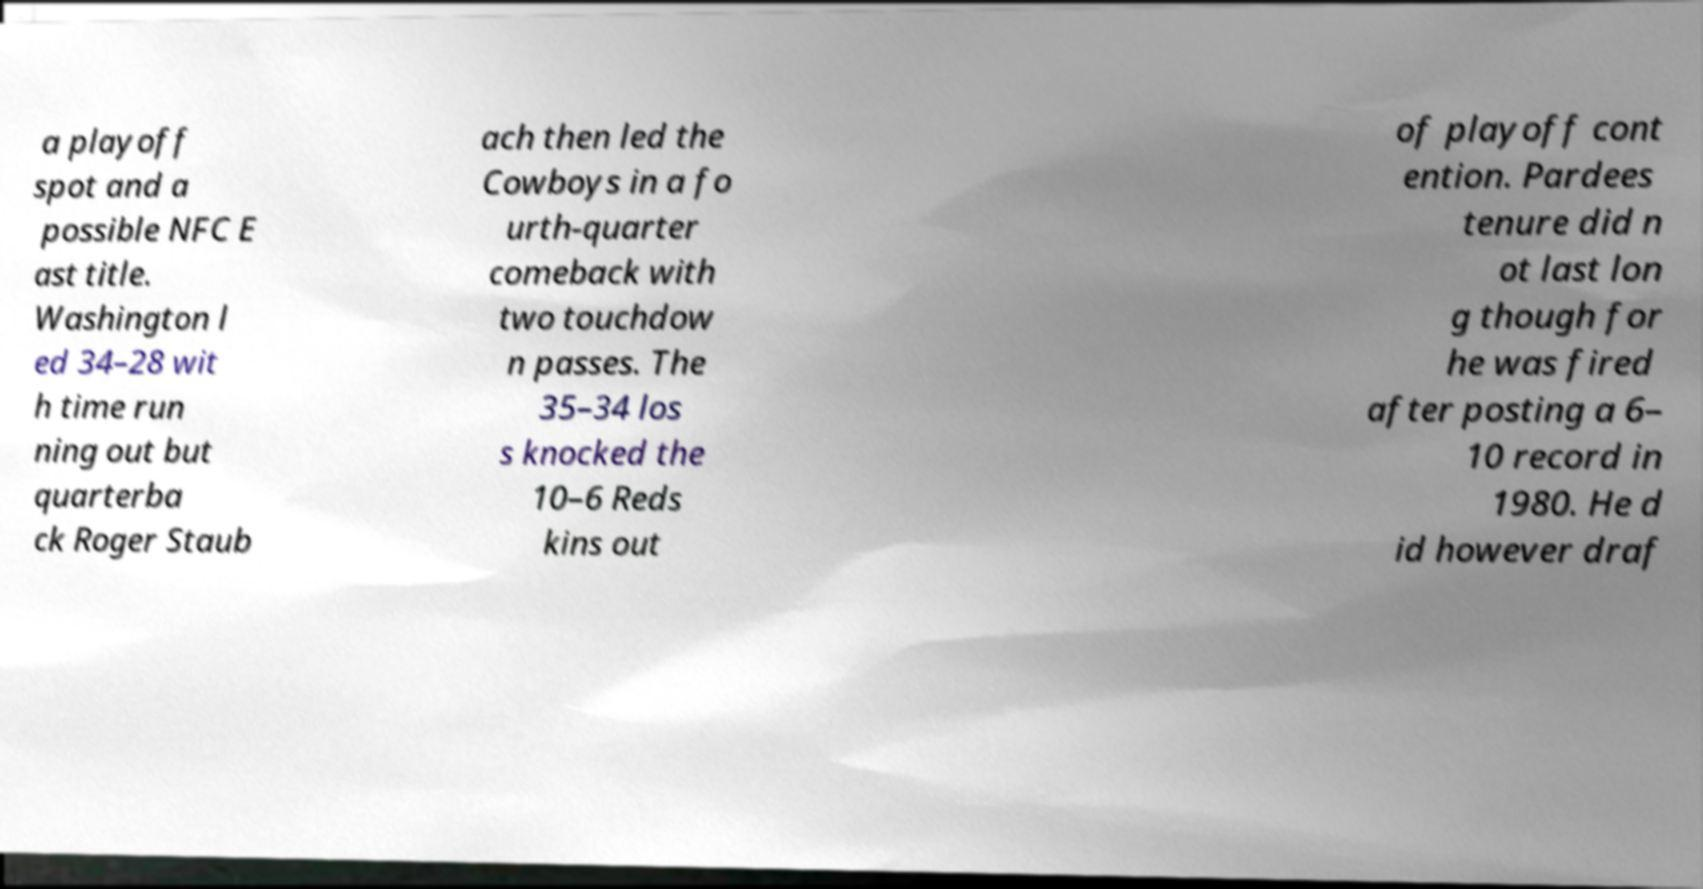Could you extract and type out the text from this image? a playoff spot and a possible NFC E ast title. Washington l ed 34–28 wit h time run ning out but quarterba ck Roger Staub ach then led the Cowboys in a fo urth-quarter comeback with two touchdow n passes. The 35–34 los s knocked the 10–6 Reds kins out of playoff cont ention. Pardees tenure did n ot last lon g though for he was fired after posting a 6– 10 record in 1980. He d id however draf 